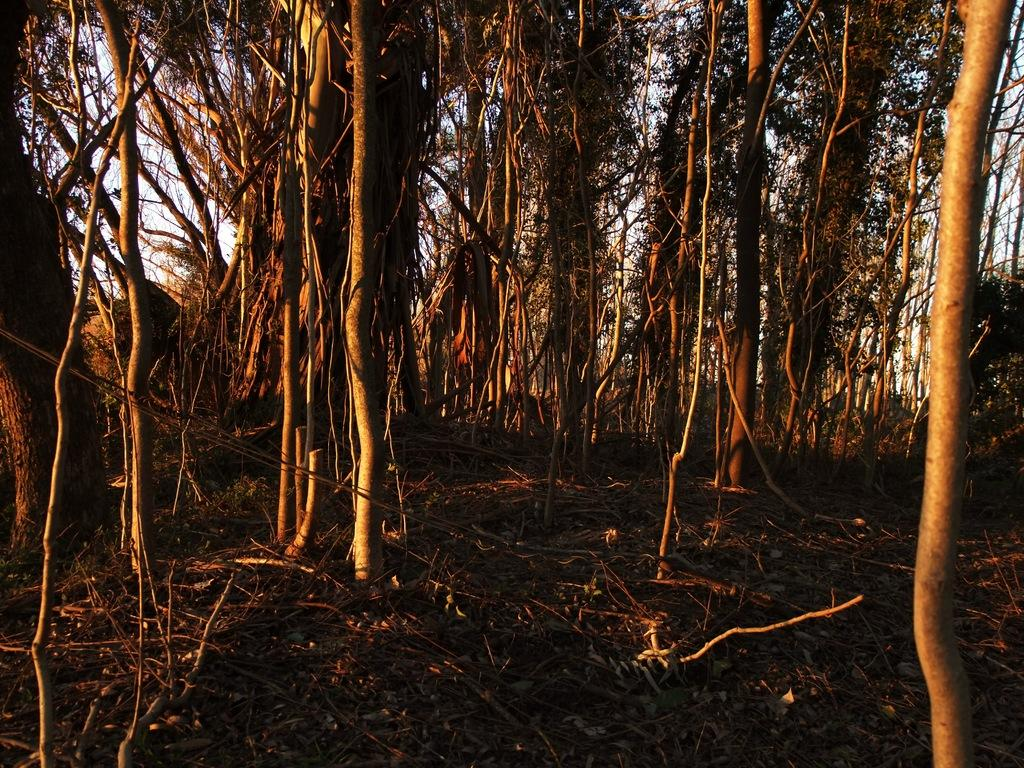What type of plant can be seen in the image? There is a tree in the image. What part of the natural environment is visible in the image? The sky is visible in the background of the image. How many years does the tree in the image represent? The image does not provide information about the age of the tree, so it cannot be determined from the image. 